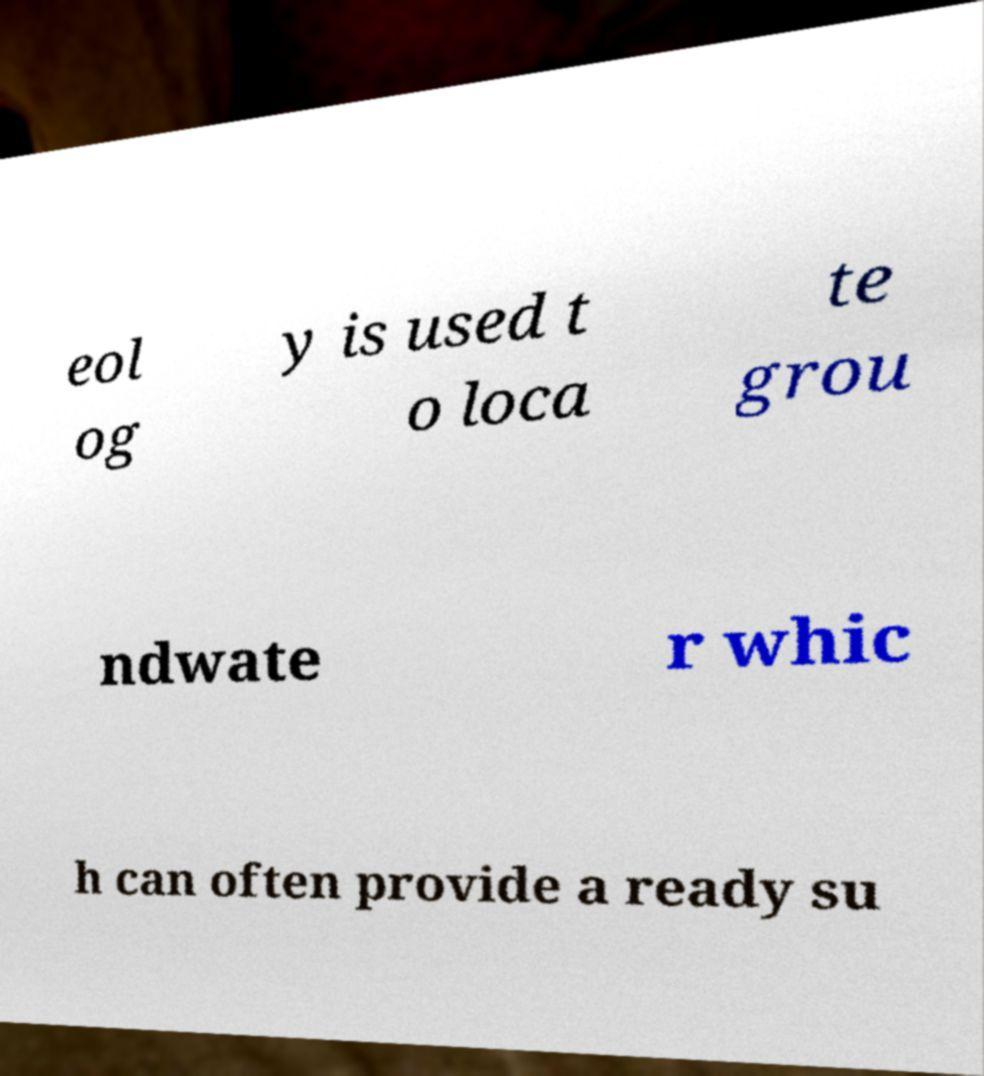Can you accurately transcribe the text from the provided image for me? eol og y is used t o loca te grou ndwate r whic h can often provide a ready su 